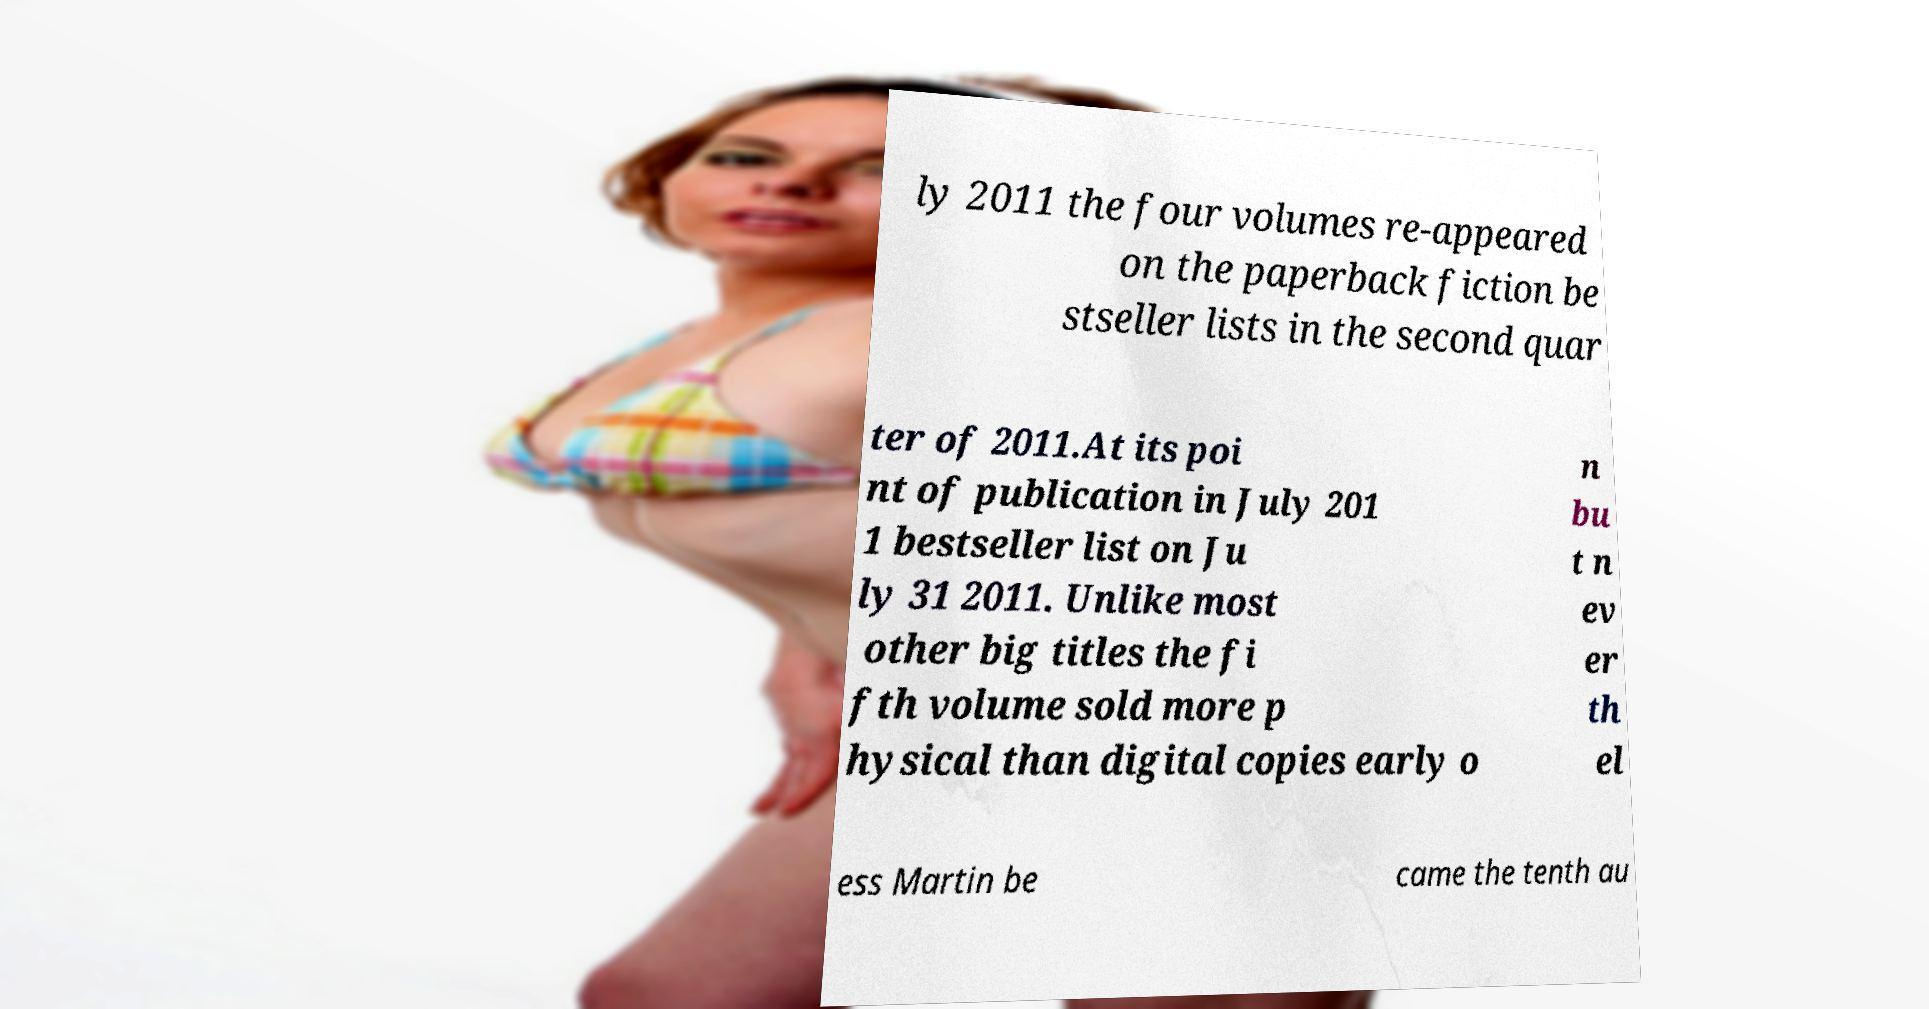Please read and relay the text visible in this image. What does it say? ly 2011 the four volumes re-appeared on the paperback fiction be stseller lists in the second quar ter of 2011.At its poi nt of publication in July 201 1 bestseller list on Ju ly 31 2011. Unlike most other big titles the fi fth volume sold more p hysical than digital copies early o n bu t n ev er th el ess Martin be came the tenth au 